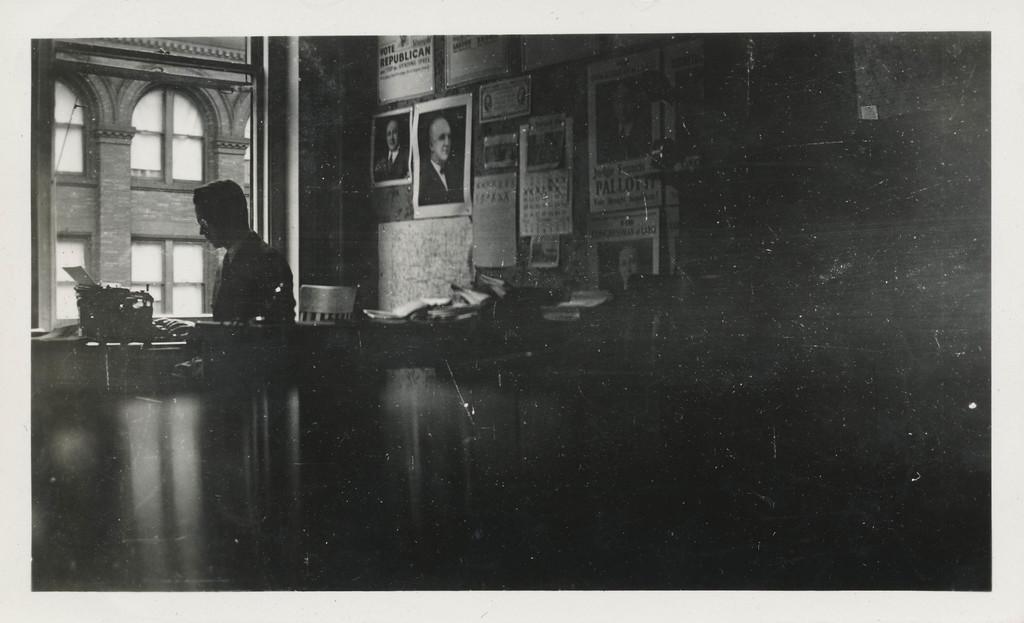In one or two sentences, can you explain what this image depicts? In this image we can see a wall with posters and a person sitting on the chair, an object in front of the person and a window beside the person. 